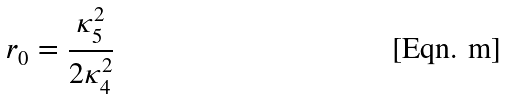<formula> <loc_0><loc_0><loc_500><loc_500>r _ { 0 } = \frac { \kappa _ { 5 } ^ { 2 } } { 2 \kappa _ { 4 } ^ { 2 } }</formula> 